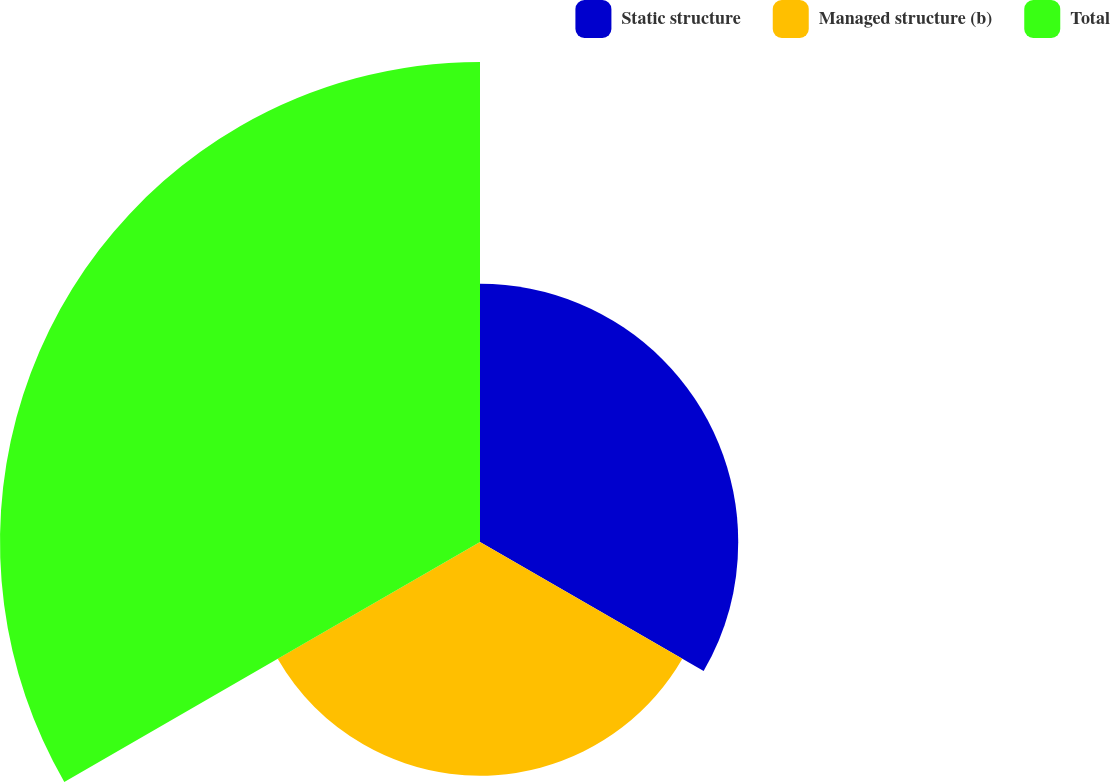<chart> <loc_0><loc_0><loc_500><loc_500><pie_chart><fcel>Static structure<fcel>Managed structure (b)<fcel>Total<nl><fcel>26.57%<fcel>24.04%<fcel>49.39%<nl></chart> 